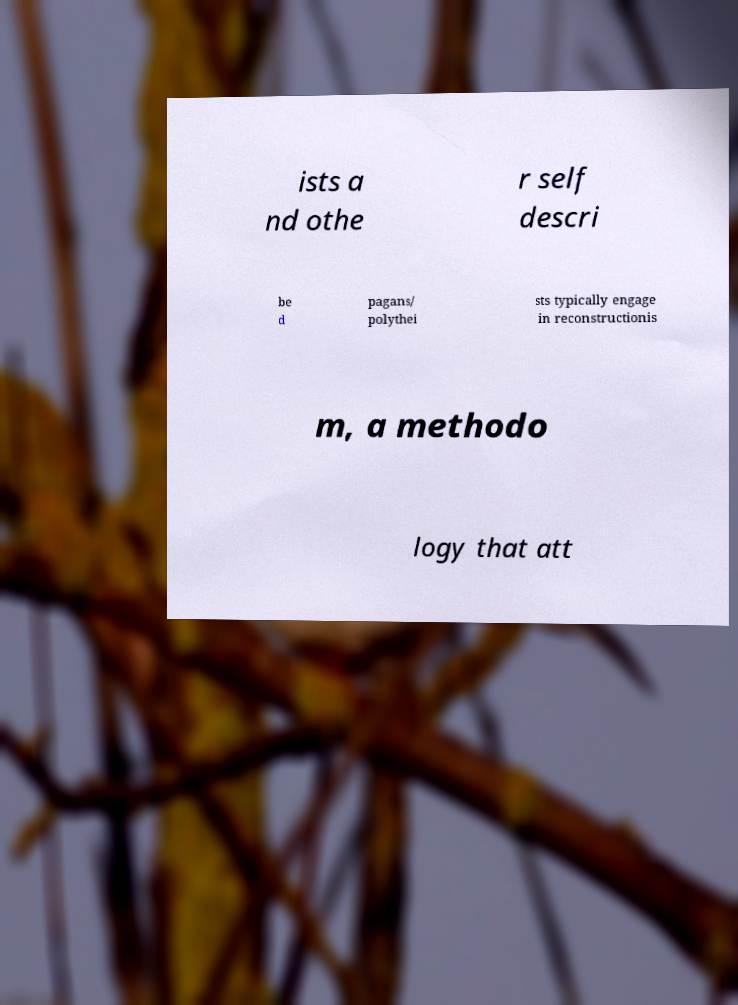Could you assist in decoding the text presented in this image and type it out clearly? ists a nd othe r self descri be d pagans/ polythei sts typically engage in reconstructionis m, a methodo logy that att 